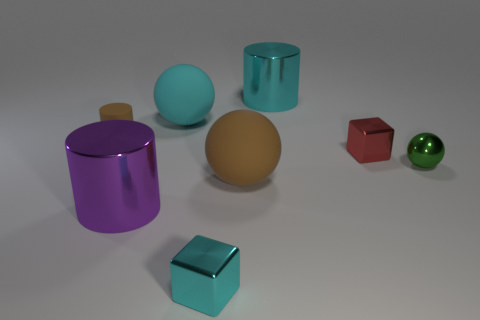What number of big cyan objects are there?
Your answer should be compact. 2. What number of cubes are large purple objects or big brown rubber things?
Keep it short and to the point. 0. What number of green balls are in front of the big metallic thing right of the big purple object?
Your response must be concise. 1. Do the red thing and the green ball have the same material?
Keep it short and to the point. Yes. What size is the rubber thing that is the same color as the tiny matte cylinder?
Your answer should be very brief. Large. Are there any red things made of the same material as the purple cylinder?
Keep it short and to the point. Yes. What color is the matte ball that is behind the small shiny block behind the large cylinder that is in front of the green sphere?
Offer a terse response. Cyan. How many purple objects are balls or small shiny things?
Your answer should be compact. 0. How many large brown things have the same shape as the tiny cyan object?
Your response must be concise. 0. What shape is the red metallic object that is the same size as the green metal object?
Your response must be concise. Cube. 